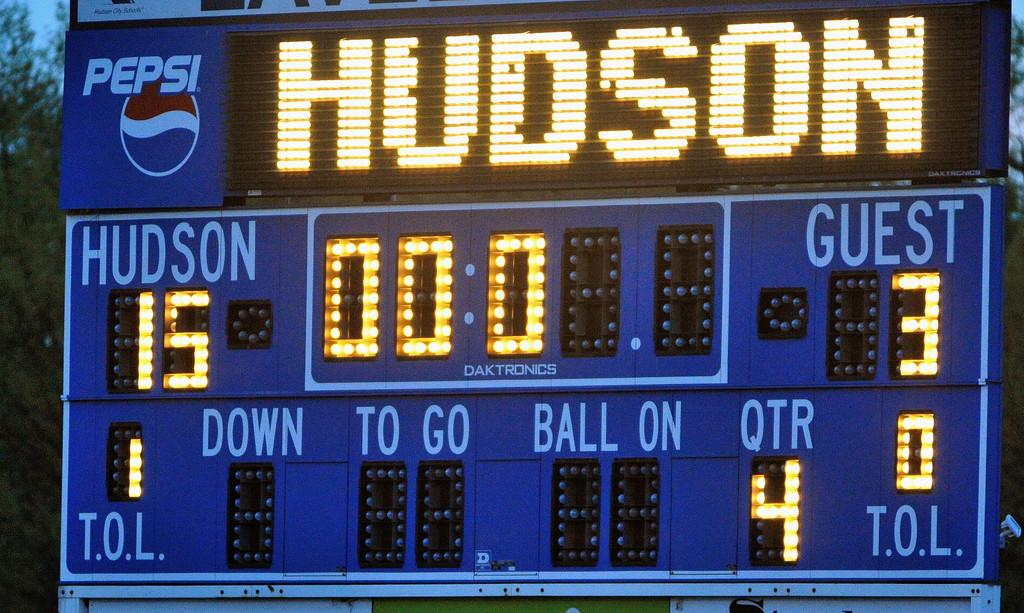Provide a one-sentence caption for the provided image. a scoreboard that had the word Hudson on it. 